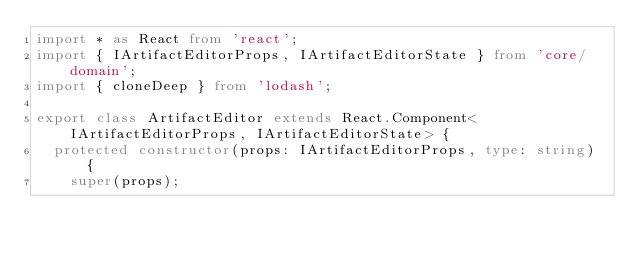Convert code to text. <code><loc_0><loc_0><loc_500><loc_500><_TypeScript_>import * as React from 'react';
import { IArtifactEditorProps, IArtifactEditorState } from 'core/domain';
import { cloneDeep } from 'lodash';

export class ArtifactEditor extends React.Component<IArtifactEditorProps, IArtifactEditorState> {
  protected constructor(props: IArtifactEditorProps, type: string) {
    super(props);</code> 